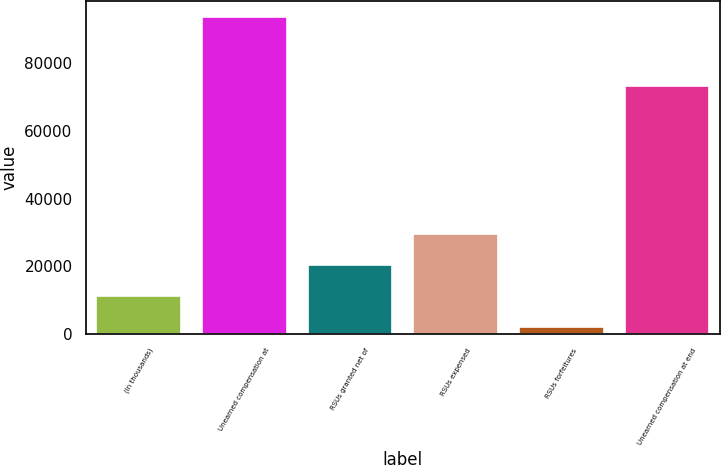Convert chart. <chart><loc_0><loc_0><loc_500><loc_500><bar_chart><fcel>(In thousands)<fcel>Unearned compensation at<fcel>RSUs granted net of<fcel>RSUs expensed<fcel>RSUs forfeitures<fcel>Unearned compensation at end<nl><fcel>11141<fcel>93653<fcel>20309<fcel>29477<fcel>1973<fcel>73205<nl></chart> 